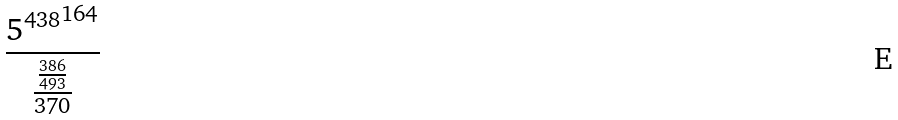Convert formula to latex. <formula><loc_0><loc_0><loc_500><loc_500>\frac { { 5 ^ { 4 3 8 } } ^ { 1 6 4 } } { \frac { \frac { 3 8 6 } { 4 9 3 } } { 3 7 0 } }</formula> 